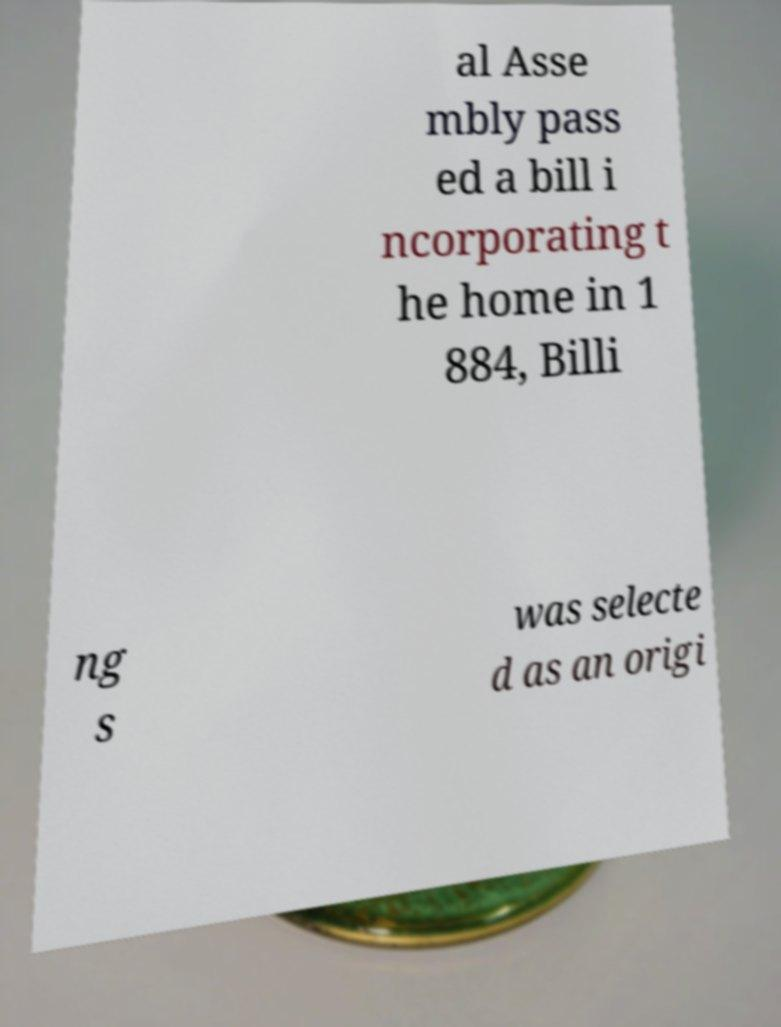Please read and relay the text visible in this image. What does it say? al Asse mbly pass ed a bill i ncorporating t he home in 1 884, Billi ng s was selecte d as an origi 